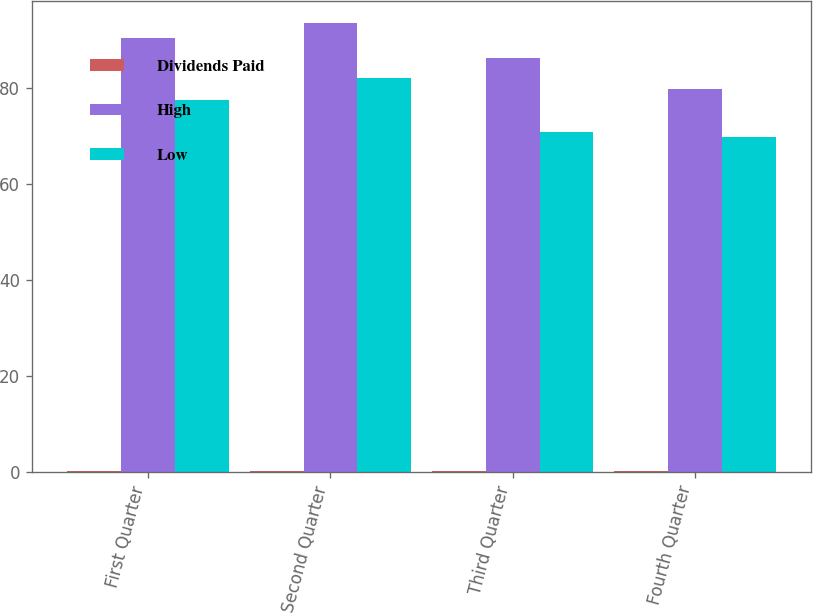Convert chart to OTSL. <chart><loc_0><loc_0><loc_500><loc_500><stacked_bar_chart><ecel><fcel>First Quarter<fcel>Second Quarter<fcel>Third Quarter<fcel>Fourth Quarter<nl><fcel>Dividends Paid<fcel>0.21<fcel>0.21<fcel>0.21<fcel>0.21<nl><fcel>High<fcel>90.46<fcel>93.5<fcel>86.32<fcel>79.73<nl><fcel>Low<fcel>77.5<fcel>82.06<fcel>70.92<fcel>69.69<nl></chart> 